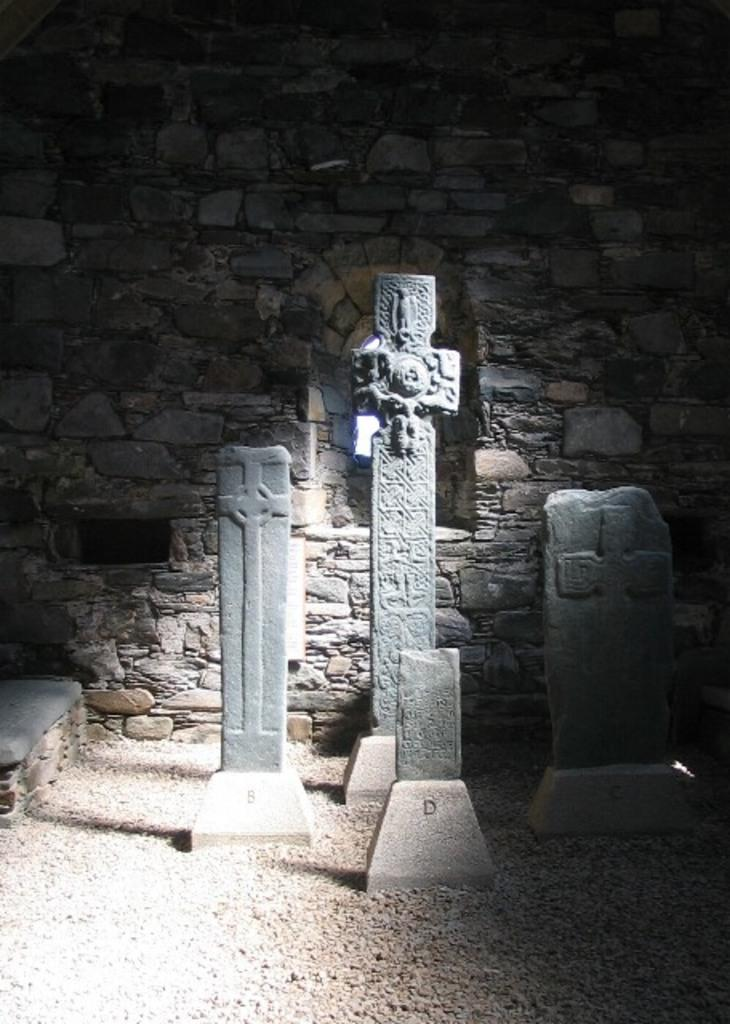What type of sculptures can be seen in the image? There are sculptures of the cross in the image. What is located at the back of the image? There is a wall at the back of the image. What is present at the bottom of the image? There are stones at the bottom of the image. What type of bomb can be seen in the image? There is no bomb present in the image; it features sculptures of the cross, a wall, and stones. What idea is being conveyed by the sculptures in the image? The image does not convey a specific idea; it simply depicts sculptures of the cross, a wall, and stones. 